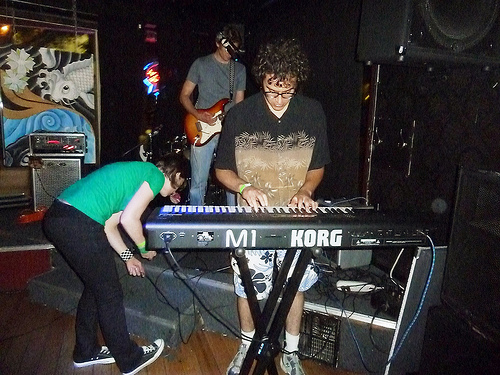<image>
Can you confirm if the man is behind the keyboard? Yes. From this viewpoint, the man is positioned behind the keyboard, with the keyboard partially or fully occluding the man. 